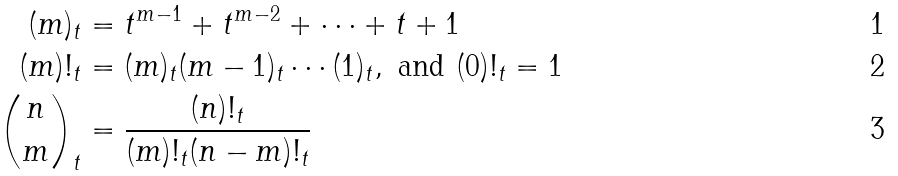<formula> <loc_0><loc_0><loc_500><loc_500>( m ) _ { t } & = t ^ { m - 1 } + t ^ { m - 2 } + \cdots + t + 1 \\ ( m ) ! _ { t } & = ( m ) _ { t } ( m - 1 ) _ { t } \cdots ( 1 ) _ { t } , \text { and } ( 0 ) ! _ { t } = 1 \\ \binom { n } { m } _ { t } & = \frac { ( n ) ! _ { t } } { ( m ) ! _ { t } ( n - m ) ! _ { t } }</formula> 